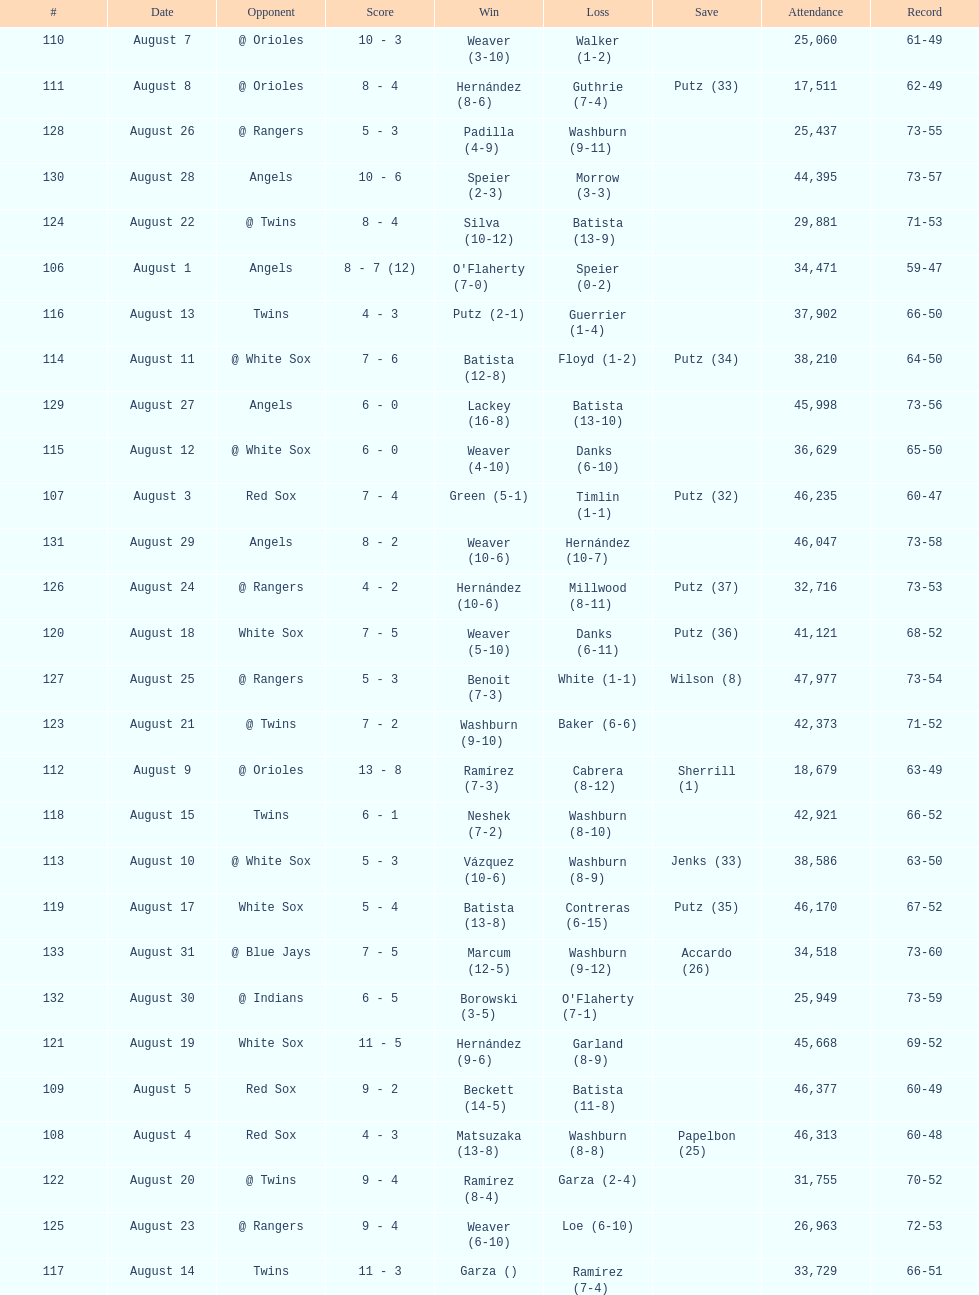Number of wins during stretch 5. 